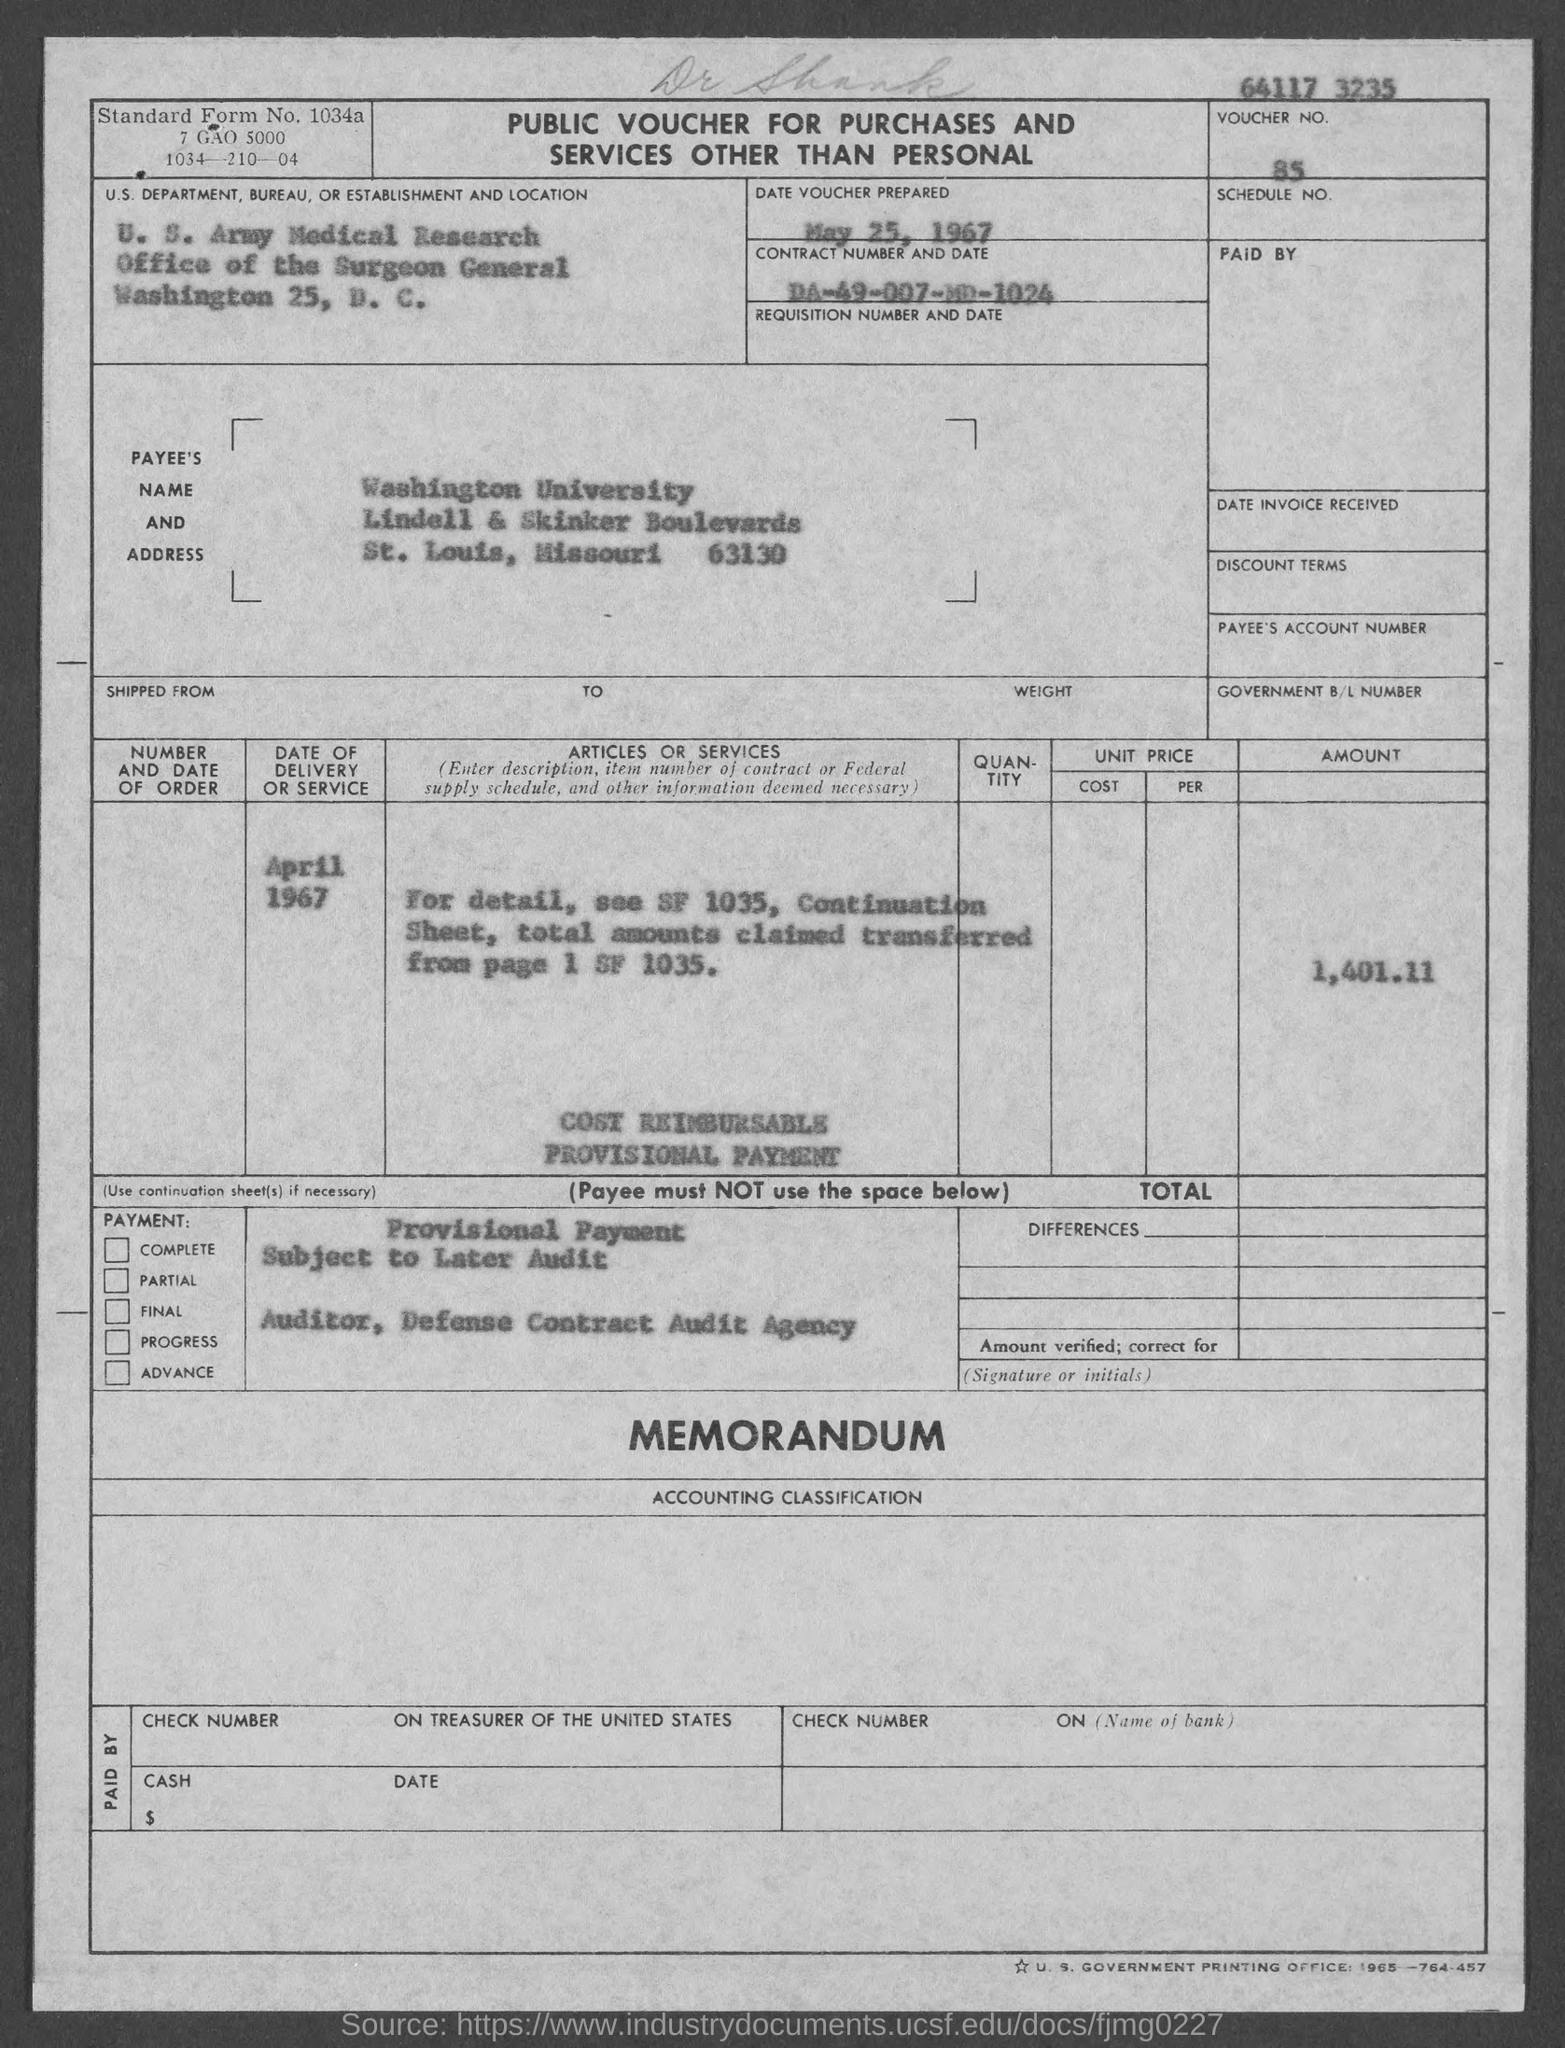Specify some key components in this picture. The voucher number mentioned in the given form is 85... The contract number mentioned in the given form is DA-49-007-MD-1024. The amount mentioned in the given form is 1,401.11 cents. The date on the voucher mentioned in the given form is May 25, 1967. 